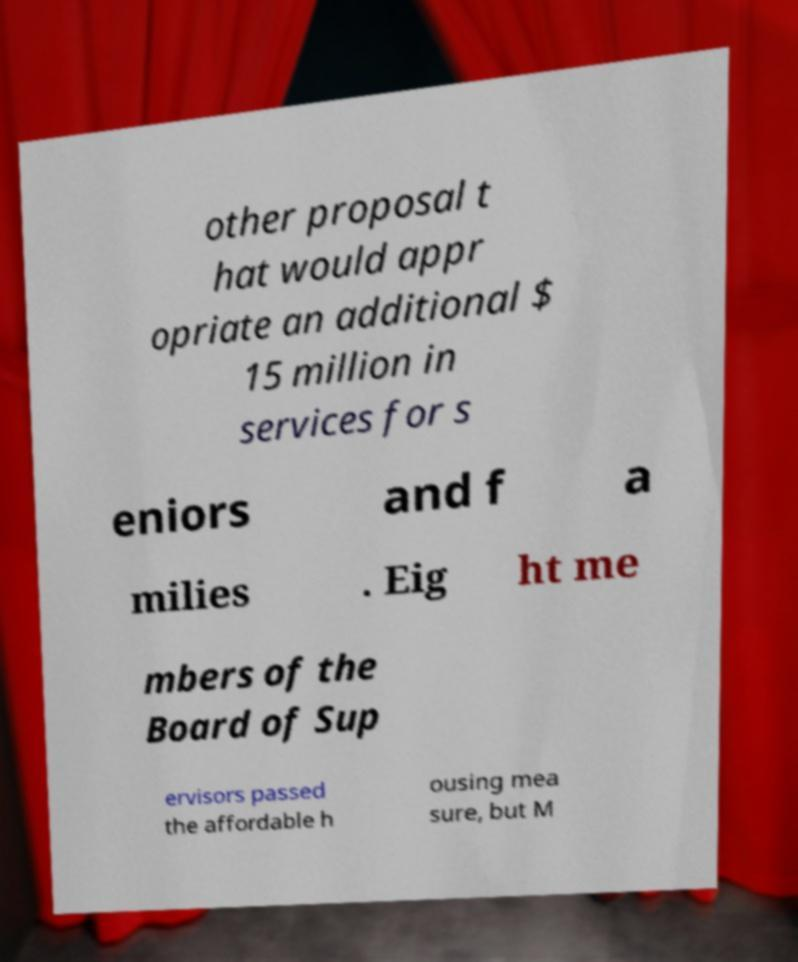Please identify and transcribe the text found in this image. other proposal t hat would appr opriate an additional $ 15 million in services for s eniors and f a milies . Eig ht me mbers of the Board of Sup ervisors passed the affordable h ousing mea sure, but M 